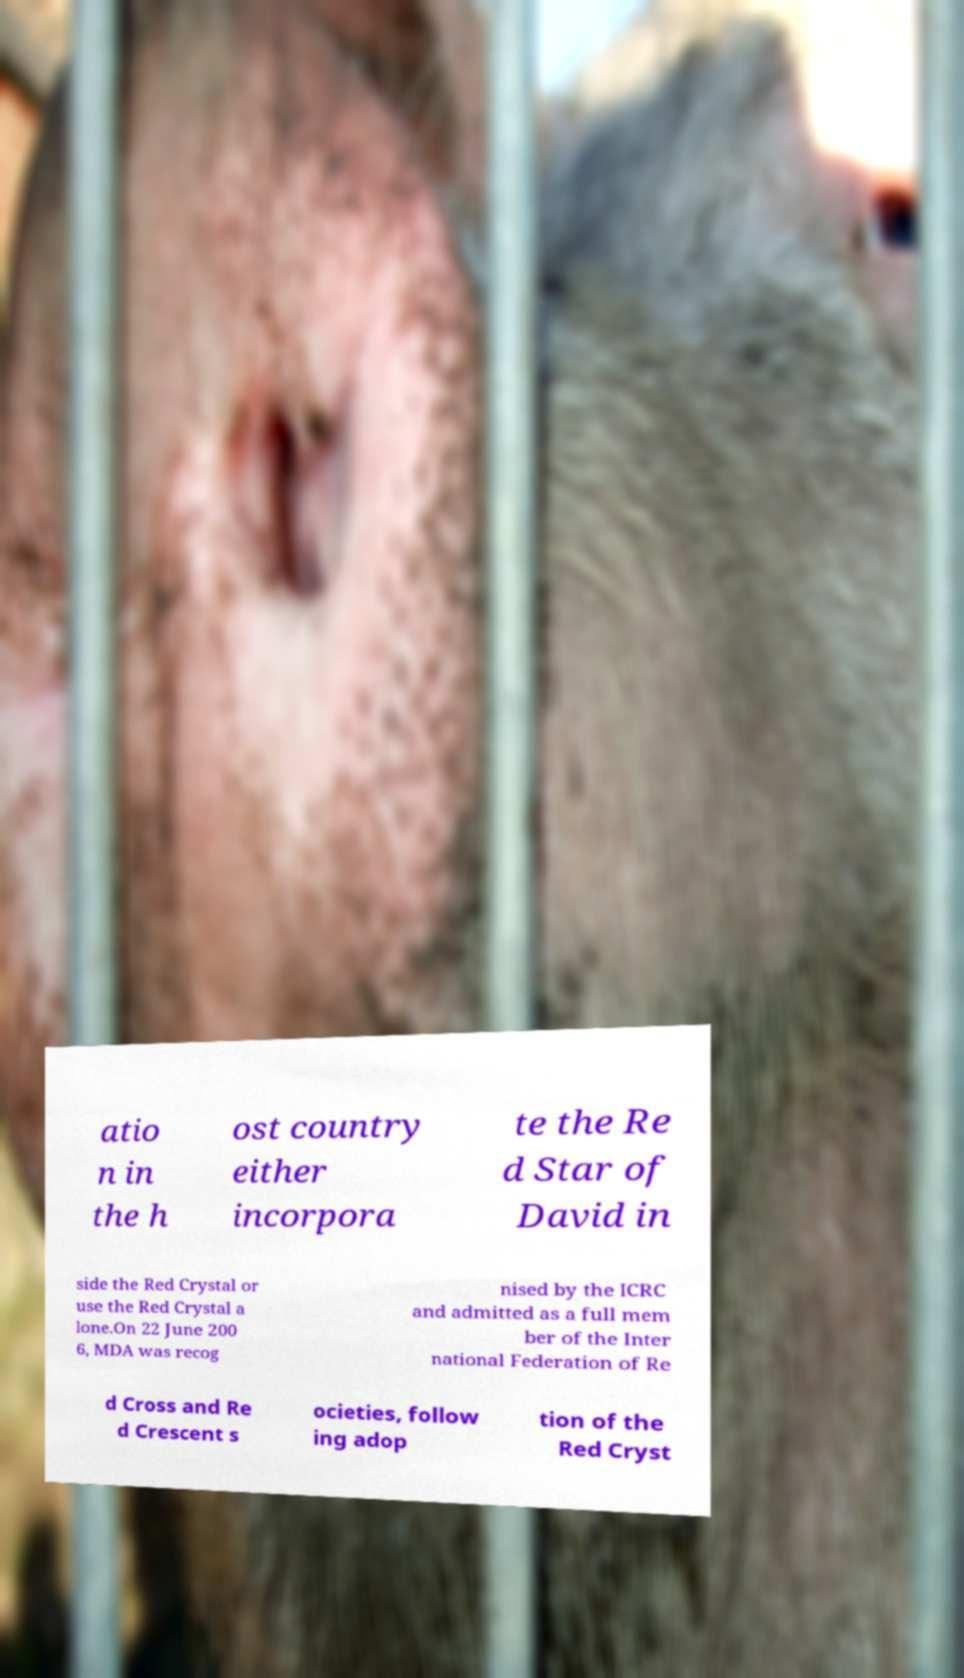For documentation purposes, I need the text within this image transcribed. Could you provide that? atio n in the h ost country either incorpora te the Re d Star of David in side the Red Crystal or use the Red Crystal a lone.On 22 June 200 6, MDA was recog nised by the ICRC and admitted as a full mem ber of the Inter national Federation of Re d Cross and Re d Crescent s ocieties, follow ing adop tion of the Red Cryst 